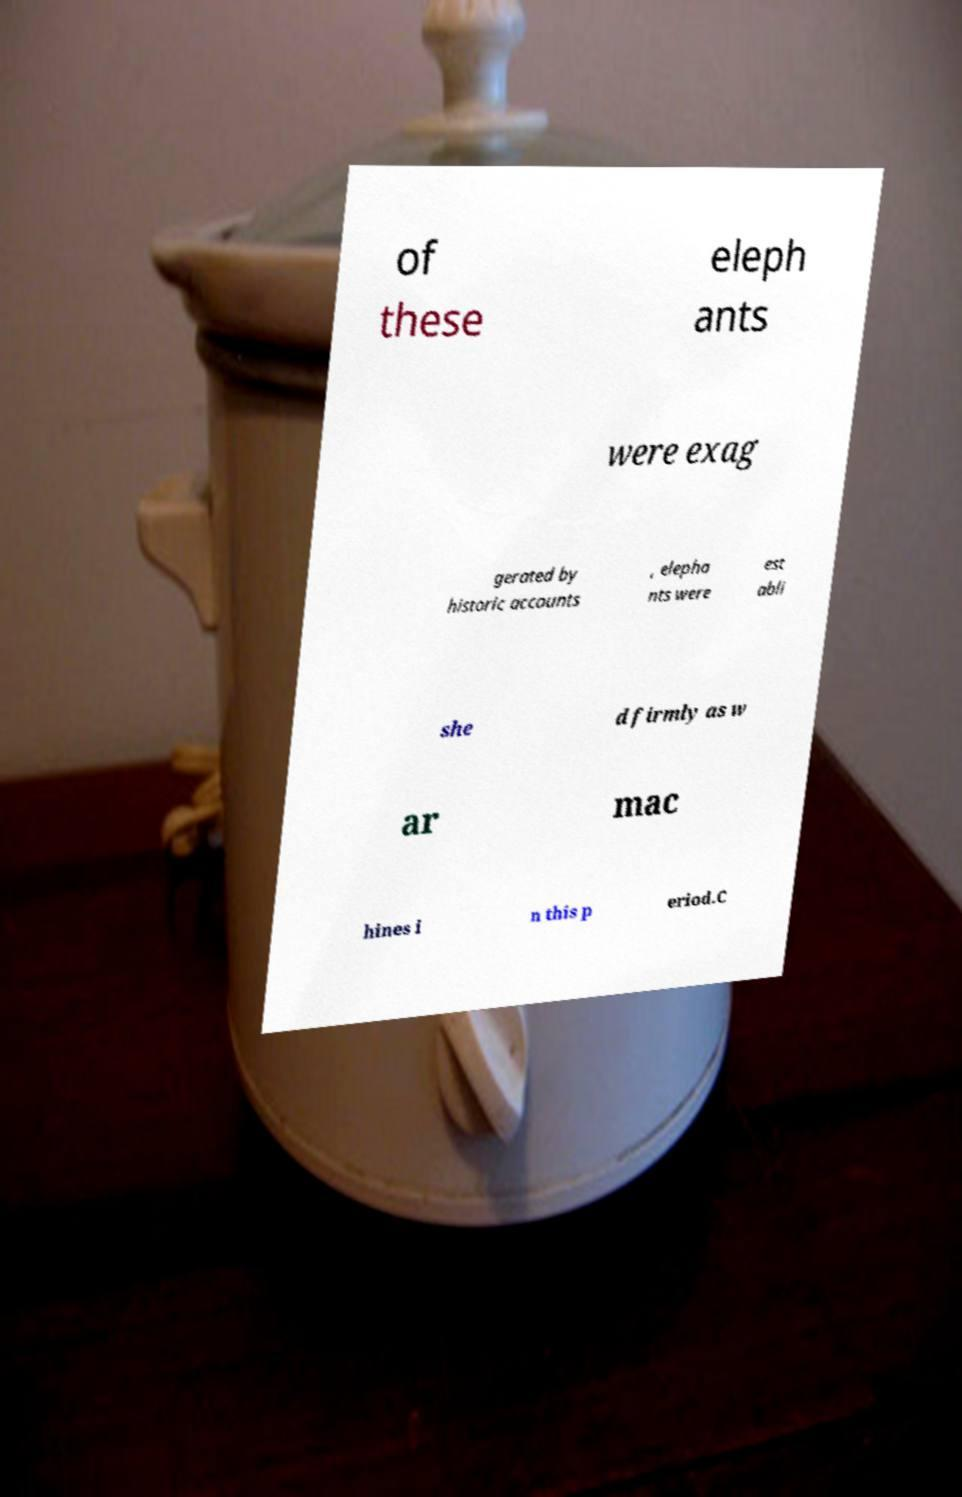Can you accurately transcribe the text from the provided image for me? of these eleph ants were exag gerated by historic accounts , elepha nts were est abli she d firmly as w ar mac hines i n this p eriod.C 